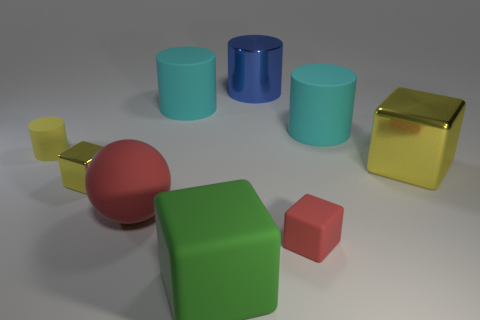Is the number of large blocks behind the large yellow shiny object greater than the number of tiny yellow matte cylinders?
Keep it short and to the point. No. The yellow thing that is made of the same material as the green object is what shape?
Keep it short and to the point. Cylinder. There is a rubber cylinder to the left of the large cyan cylinder that is to the left of the red cube; what color is it?
Make the answer very short. Yellow. Is the shape of the big red object the same as the large blue object?
Your answer should be compact. No. There is another tiny object that is the same shape as the blue metallic object; what is its material?
Your response must be concise. Rubber. There is a large metal thing in front of the cylinder that is on the right side of the blue thing; is there a metallic block to the right of it?
Your response must be concise. No. Does the large blue object have the same shape as the tiny matte thing that is in front of the big red sphere?
Give a very brief answer. No. Is there any other thing that has the same color as the small shiny cube?
Offer a very short reply. Yes. Does the big block that is in front of the big red rubber thing have the same color as the large block behind the large matte sphere?
Keep it short and to the point. No. Is there a large blue metallic ball?
Offer a terse response. No. 